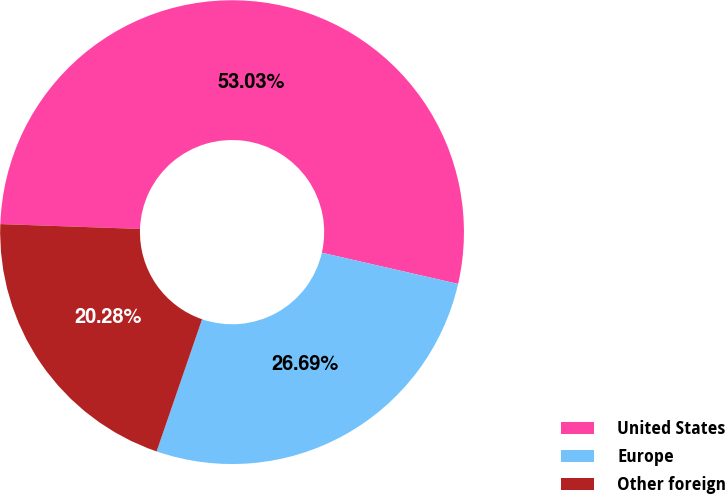Convert chart to OTSL. <chart><loc_0><loc_0><loc_500><loc_500><pie_chart><fcel>United States<fcel>Europe<fcel>Other foreign<nl><fcel>53.03%<fcel>26.69%<fcel>20.28%<nl></chart> 